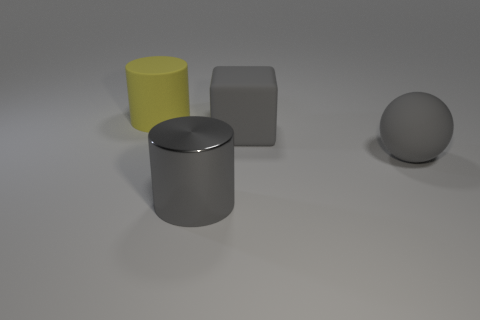Add 2 big gray matte objects. How many objects exist? 6 Subtract 0 blue blocks. How many objects are left? 4 Subtract all cubes. How many objects are left? 3 Subtract 1 balls. How many balls are left? 0 Subtract all green blocks. Subtract all blue cylinders. How many blocks are left? 1 Subtract all brown balls. How many gray cylinders are left? 1 Subtract all rubber balls. Subtract all large rubber cubes. How many objects are left? 2 Add 1 large rubber things. How many large rubber things are left? 4 Add 1 brown metallic cylinders. How many brown metallic cylinders exist? 1 Subtract all yellow cylinders. How many cylinders are left? 1 